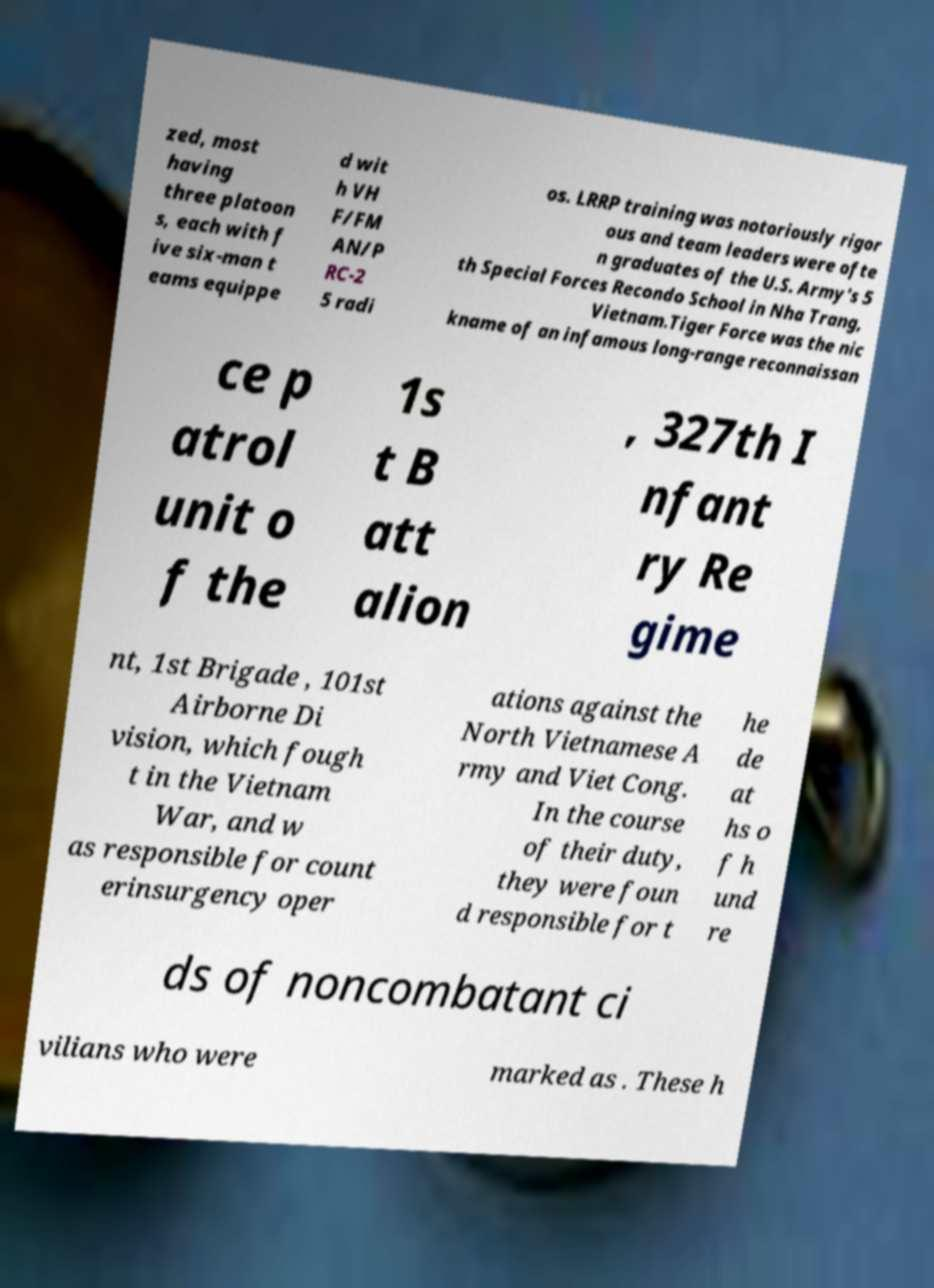I need the written content from this picture converted into text. Can you do that? zed, most having three platoon s, each with f ive six-man t eams equippe d wit h VH F/FM AN/P RC-2 5 radi os. LRRP training was notoriously rigor ous and team leaders were ofte n graduates of the U.S. Army's 5 th Special Forces Recondo School in Nha Trang, Vietnam.Tiger Force was the nic kname of an infamous long-range reconnaissan ce p atrol unit o f the 1s t B att alion , 327th I nfant ry Re gime nt, 1st Brigade , 101st Airborne Di vision, which fough t in the Vietnam War, and w as responsible for count erinsurgency oper ations against the North Vietnamese A rmy and Viet Cong. In the course of their duty, they were foun d responsible for t he de at hs o f h und re ds of noncombatant ci vilians who were marked as . These h 